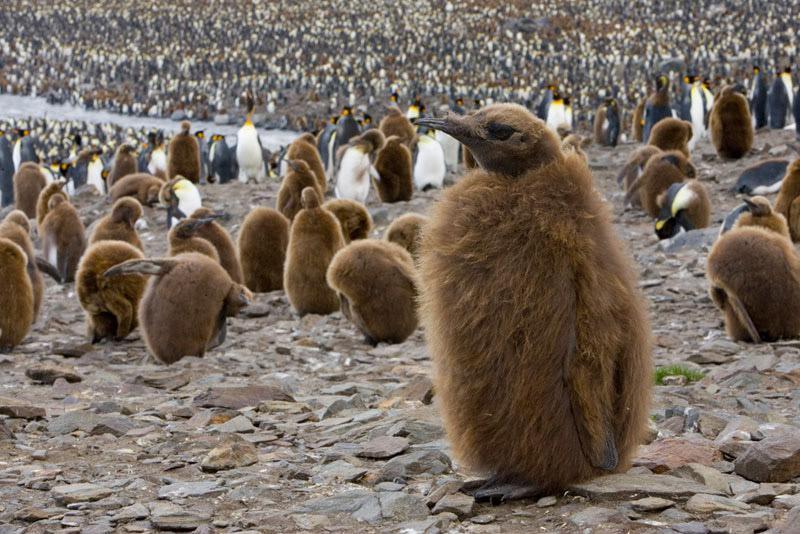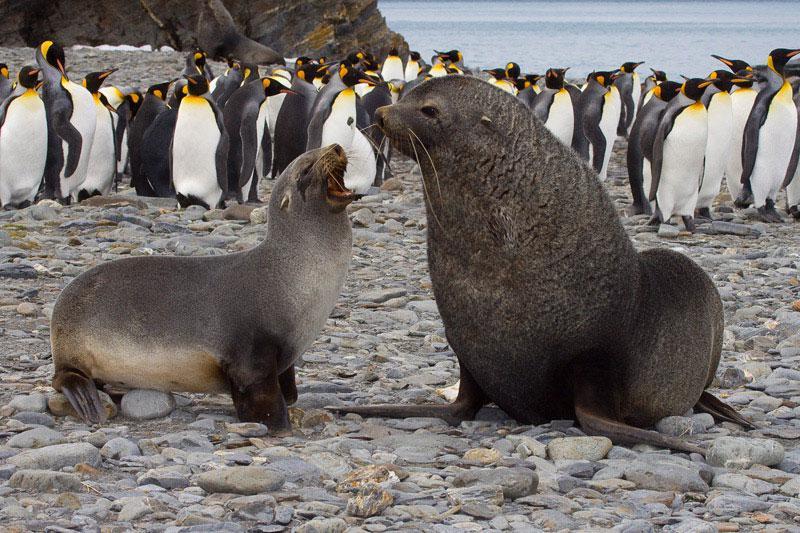The first image is the image on the left, the second image is the image on the right. For the images shown, is this caption "Just one black and white penguin is visible in one image." true? Answer yes or no. No. The first image is the image on the left, the second image is the image on the right. Given the left and right images, does the statement "A hilly landform is behind some of the penguins." hold true? Answer yes or no. Yes. 